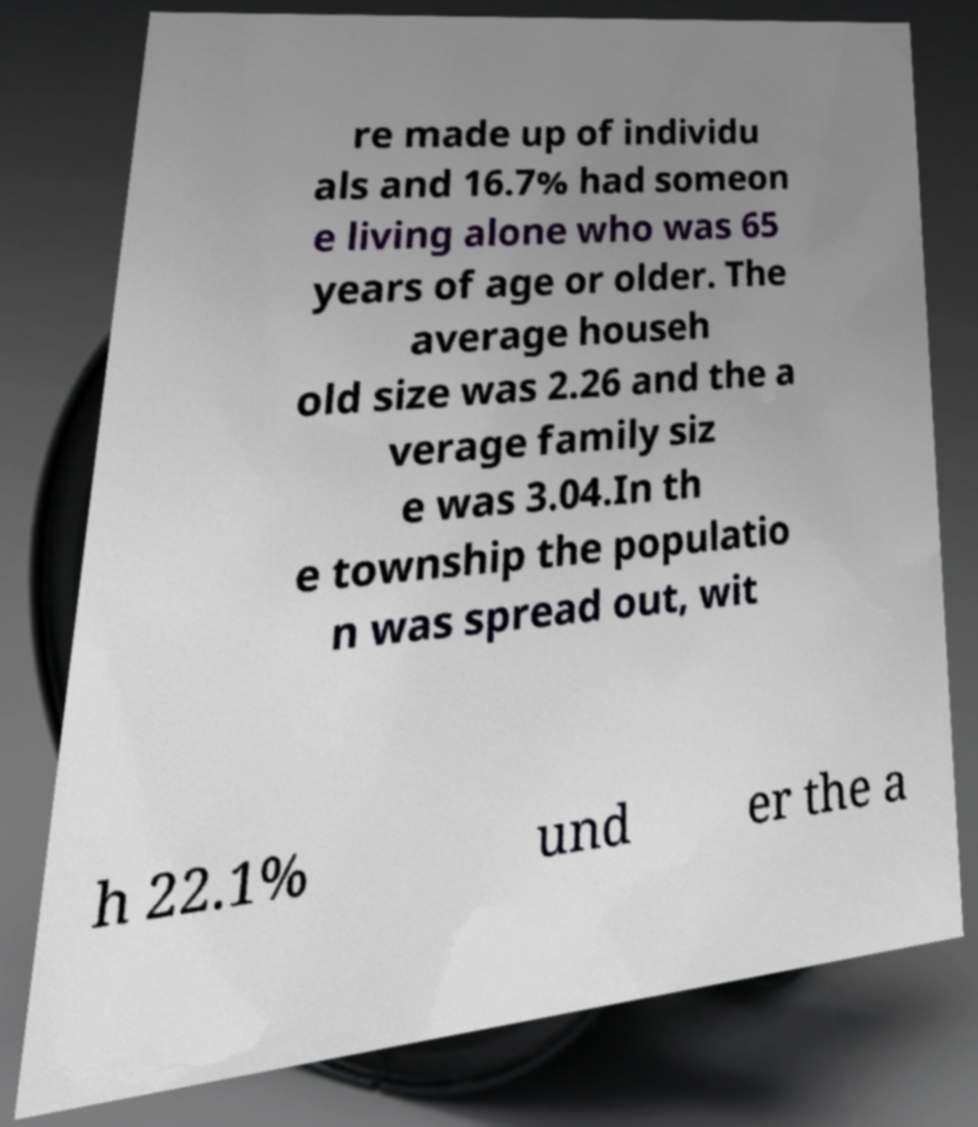What messages or text are displayed in this image? I need them in a readable, typed format. re made up of individu als and 16.7% had someon e living alone who was 65 years of age or older. The average househ old size was 2.26 and the a verage family siz e was 3.04.In th e township the populatio n was spread out, wit h 22.1% und er the a 